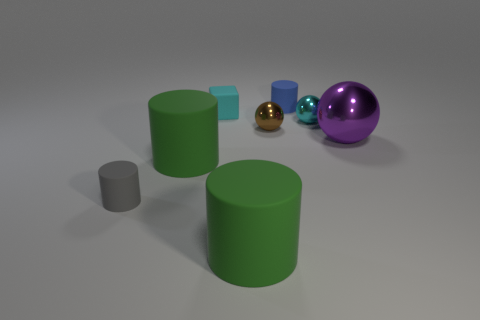Add 2 shiny blocks. How many objects exist? 10 Subtract all spheres. How many objects are left? 5 Subtract 0 yellow spheres. How many objects are left? 8 Subtract all large green matte cylinders. Subtract all tiny brown objects. How many objects are left? 5 Add 6 small gray matte objects. How many small gray matte objects are left? 7 Add 2 big purple metal balls. How many big purple metal balls exist? 3 